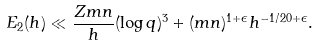Convert formula to latex. <formula><loc_0><loc_0><loc_500><loc_500>E _ { 2 } ( h ) \ll \frac { Z m n } { h } ( \log q ) ^ { 3 } + ( m n ) ^ { 1 + \epsilon } h ^ { - 1 / 2 0 + \epsilon } .</formula> 